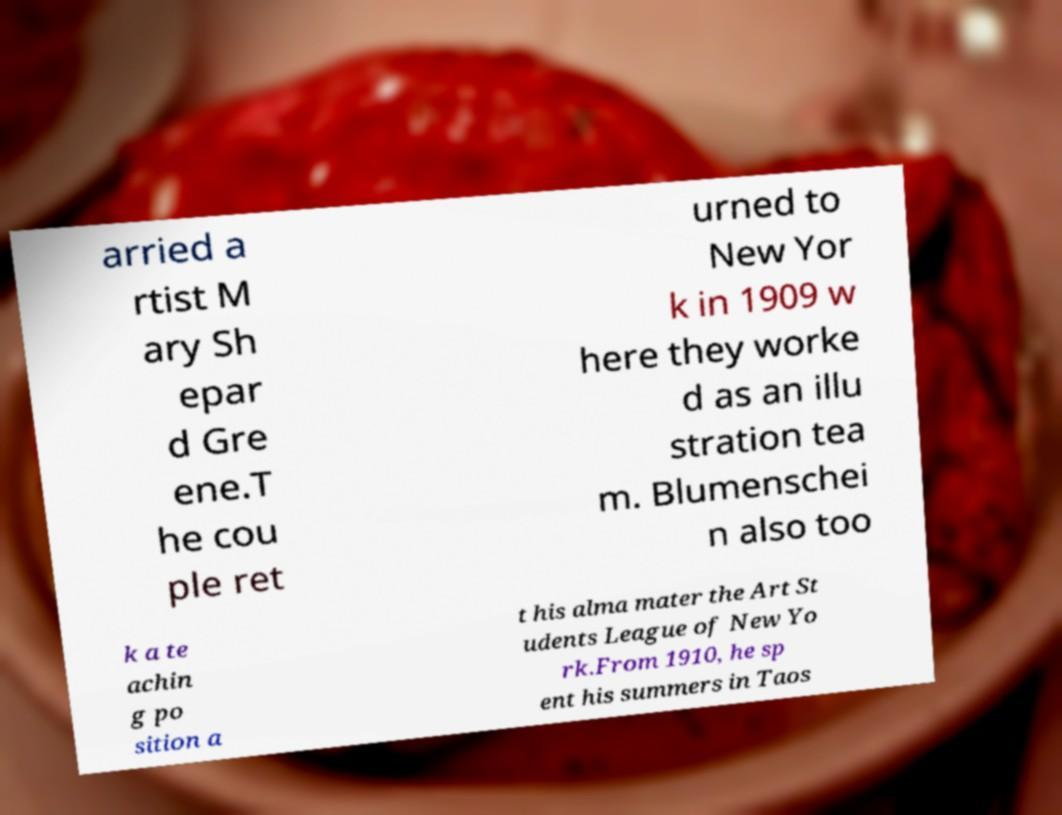I need the written content from this picture converted into text. Can you do that? arried a rtist M ary Sh epar d Gre ene.T he cou ple ret urned to New Yor k in 1909 w here they worke d as an illu stration tea m. Blumenschei n also too k a te achin g po sition a t his alma mater the Art St udents League of New Yo rk.From 1910, he sp ent his summers in Taos 